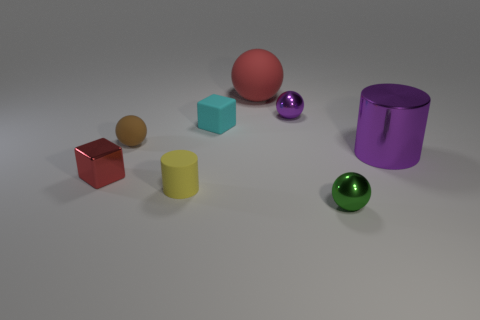Subtract all small green metal balls. How many balls are left? 3 Add 1 large spheres. How many objects exist? 9 Subtract all red spheres. How many spheres are left? 3 Subtract 3 spheres. How many spheres are left? 1 Add 5 tiny purple metal balls. How many tiny purple metal balls exist? 6 Subtract 1 red balls. How many objects are left? 7 Subtract all cyan blocks. Subtract all purple cylinders. How many blocks are left? 1 Subtract all rubber objects. Subtract all cyan blocks. How many objects are left? 3 Add 5 big red objects. How many big red objects are left? 6 